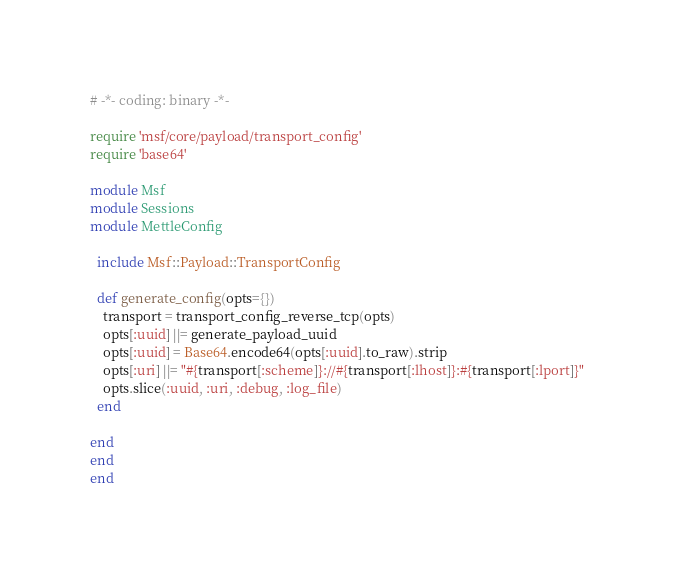<code> <loc_0><loc_0><loc_500><loc_500><_Ruby_># -*- coding: binary -*-

require 'msf/core/payload/transport_config'
require 'base64'

module Msf
module Sessions
module MettleConfig

  include Msf::Payload::TransportConfig

  def generate_config(opts={})
    transport = transport_config_reverse_tcp(opts)
    opts[:uuid] ||= generate_payload_uuid
    opts[:uuid] = Base64.encode64(opts[:uuid].to_raw).strip
    opts[:uri] ||= "#{transport[:scheme]}://#{transport[:lhost]}:#{transport[:lport]}"
    opts.slice(:uuid, :uri, :debug, :log_file)
  end

end
end
end
</code> 